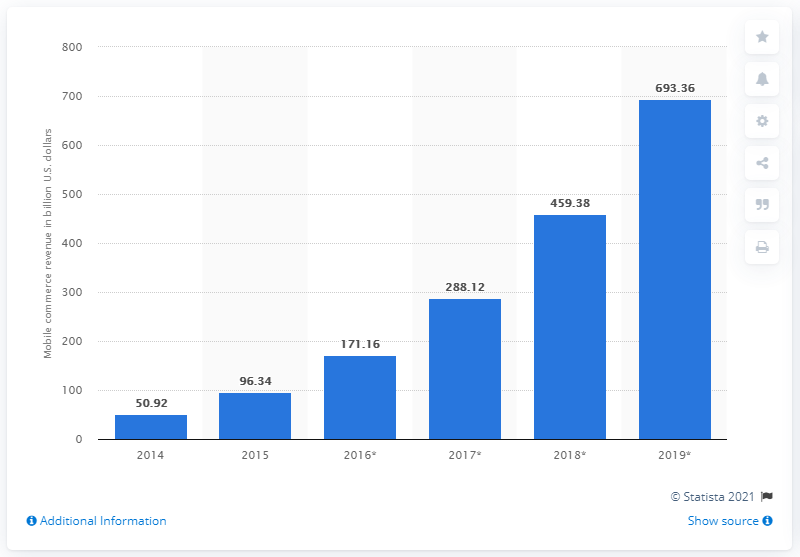Draw attention to some important aspects in this diagram. In 2015, the global mobile commerce revenue was approximately $96.34 billion. According to projections, global mobile commerce revenues in 2019 are expected to reach $693.36 million. 